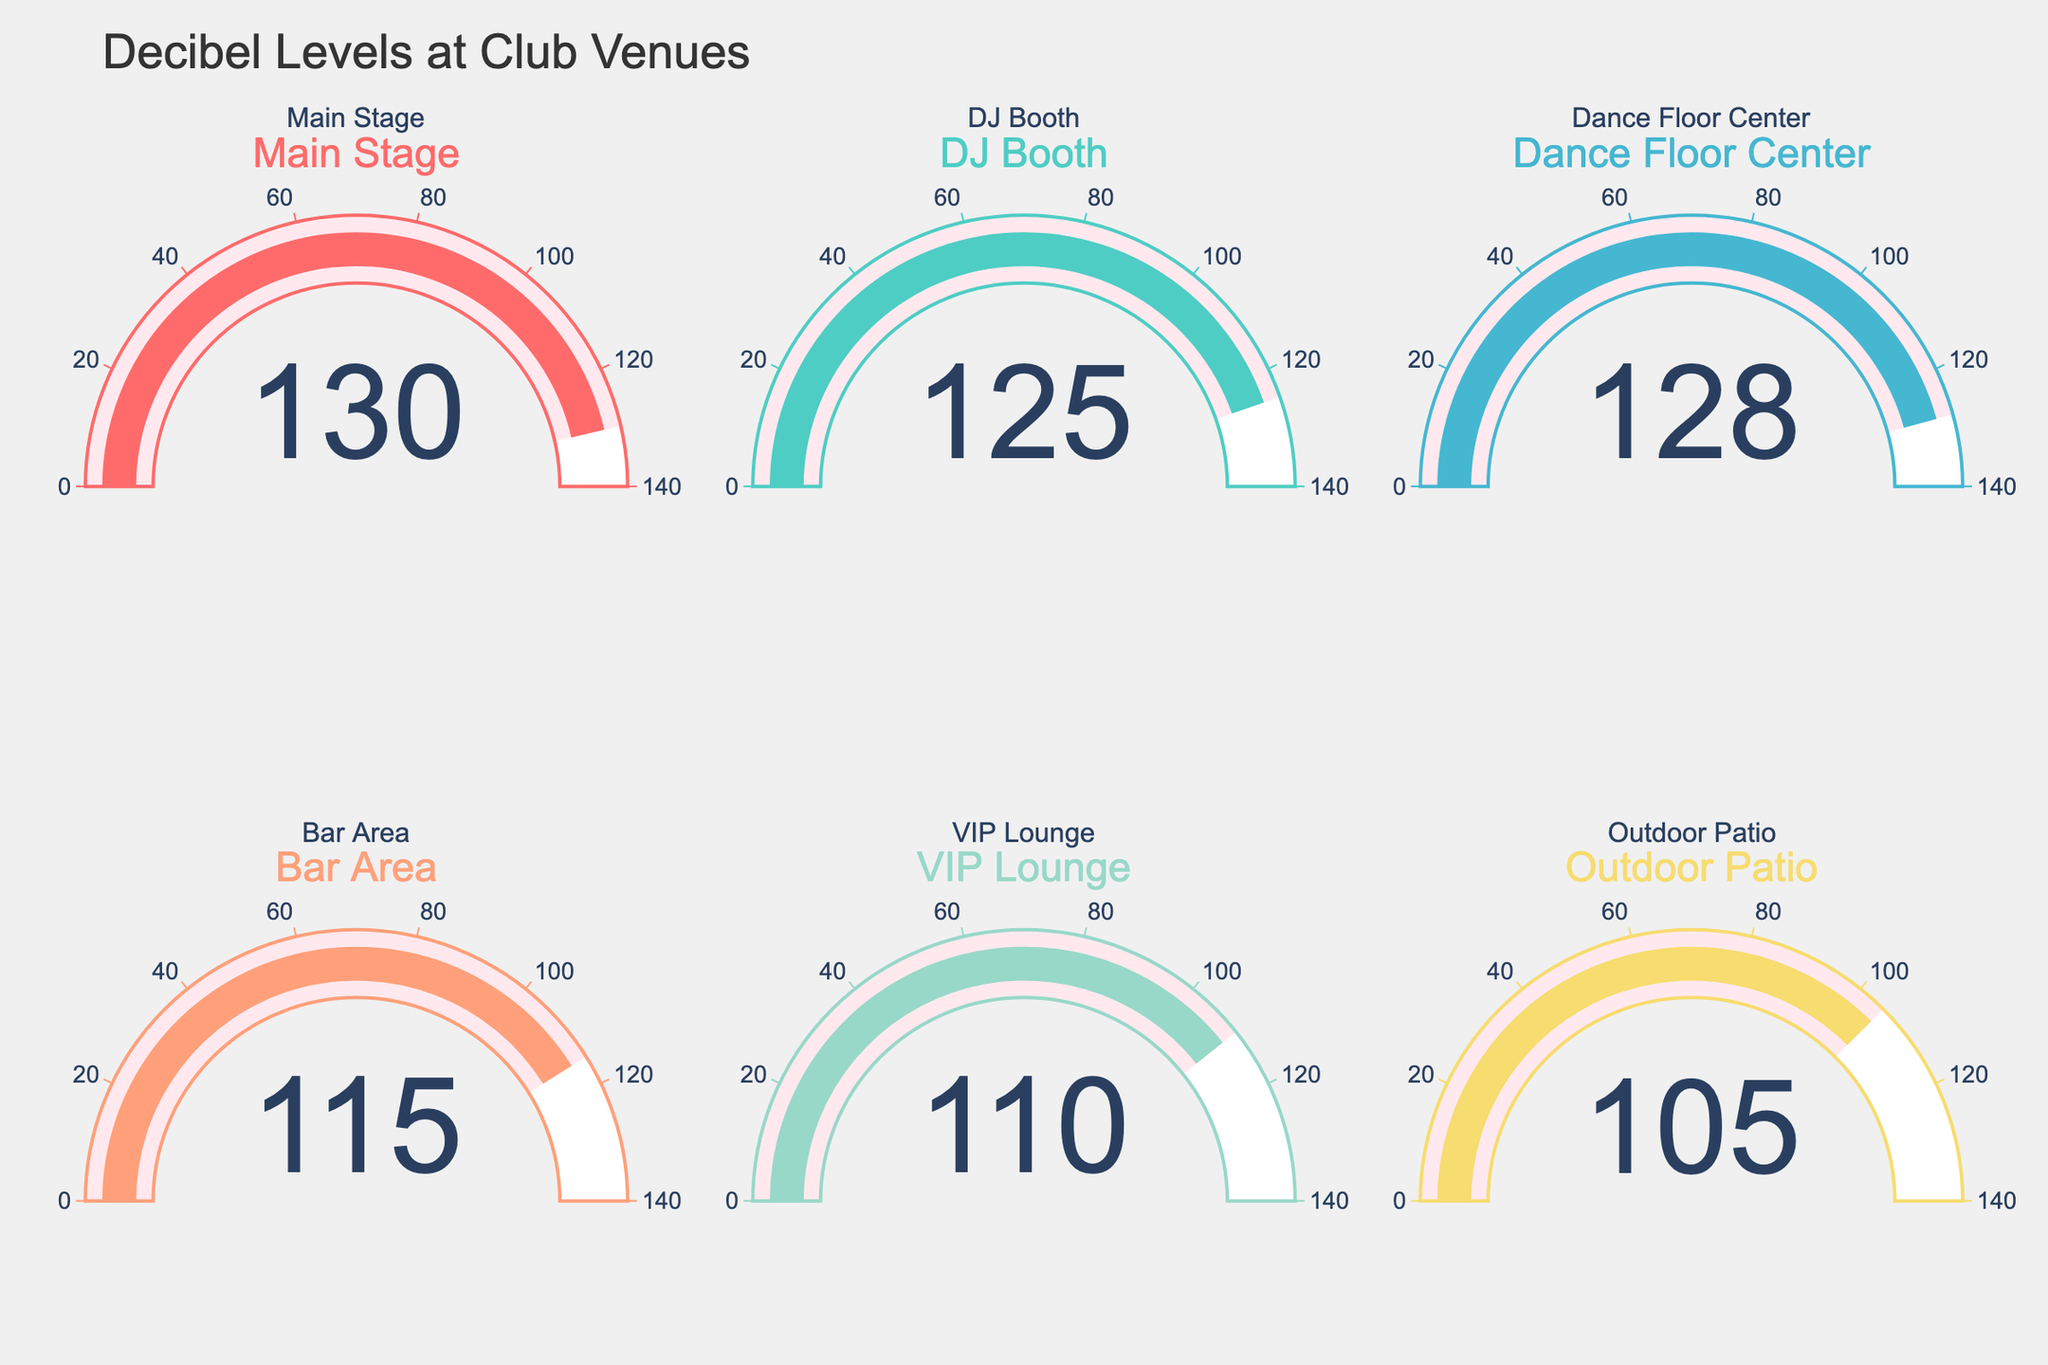What is the Decibel level at the Main Stage? Look at the gauge chart labeled "Main Stage" to identify the number displayed.
Answer: 130 Put the Decibel levels in ascending order. List all the displayed Decibel levels and then sort them from smallest to largest. The values are 130, 125, 128, 115, 110, 105.
Answer: 105, 110, 115, 125, 128, 130 What is the difference in Decibel levels between the DJ Booth and the Outdoor Patio? Look at the Decibel levels of the DJ Booth (125) and the Outdoor Patio (105) and subtract them. 125 - 105 = 20.
Answer: 20 Which area has the second lowest Decibel level? Organize the Decibel levels in ascending order: 105, 110, 115, 125, 128, 130. The second lowest is 110, which is the VIP Lounge.
Answer: VIP Lounge What is the average Decibel level for all the areas? Sum all the Decibel levels (130 + 125 + 128 + 115 + 110 + 105 = 713) and divide by the number of areas (6). 713 / 6 = 118.83.
Answer: 118.83 Which area has the highest Decibel level? Identify the highest number displayed on any of the gauges. The Main Stage shows 130, which is the highest.
Answer: Main Stage Is the Decibel level at the Dance Floor Center greater than at the Bar Area? Compare the Decibel levels displayed for Dance Floor Center (128) and Bar Area (115). 128 is greater than 115.
Answer: Yes How much louder is the Main Stage compared to the VIP Lounge? Subtract the Decibel level of the VIP Lounge (110) from that of the Main Stage (130). 130 - 110 = 20.
Answer: 20 What is the cumulative Decibel level for the DJ Booth and Bar Area? Add the Decibel levels of the DJ Booth (125) and Bar Area (115). 125 + 115 = 240.
Answer: 240 